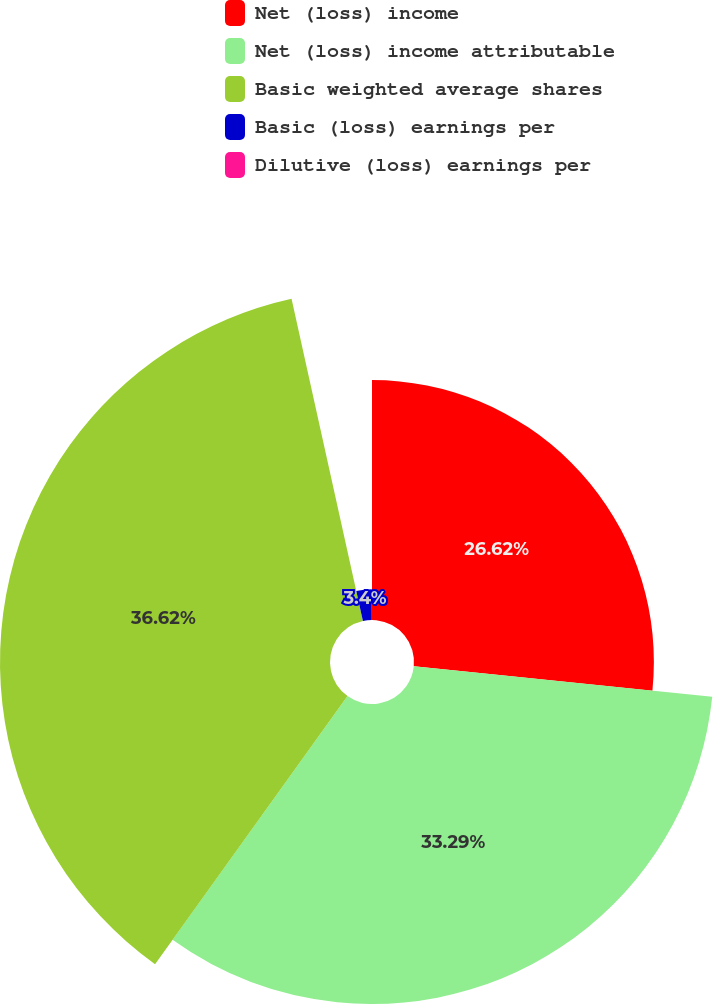Convert chart to OTSL. <chart><loc_0><loc_0><loc_500><loc_500><pie_chart><fcel>Net (loss) income<fcel>Net (loss) income attributable<fcel>Basic weighted average shares<fcel>Basic (loss) earnings per<fcel>Dilutive (loss) earnings per<nl><fcel>26.62%<fcel>33.29%<fcel>36.62%<fcel>3.4%<fcel>0.07%<nl></chart> 